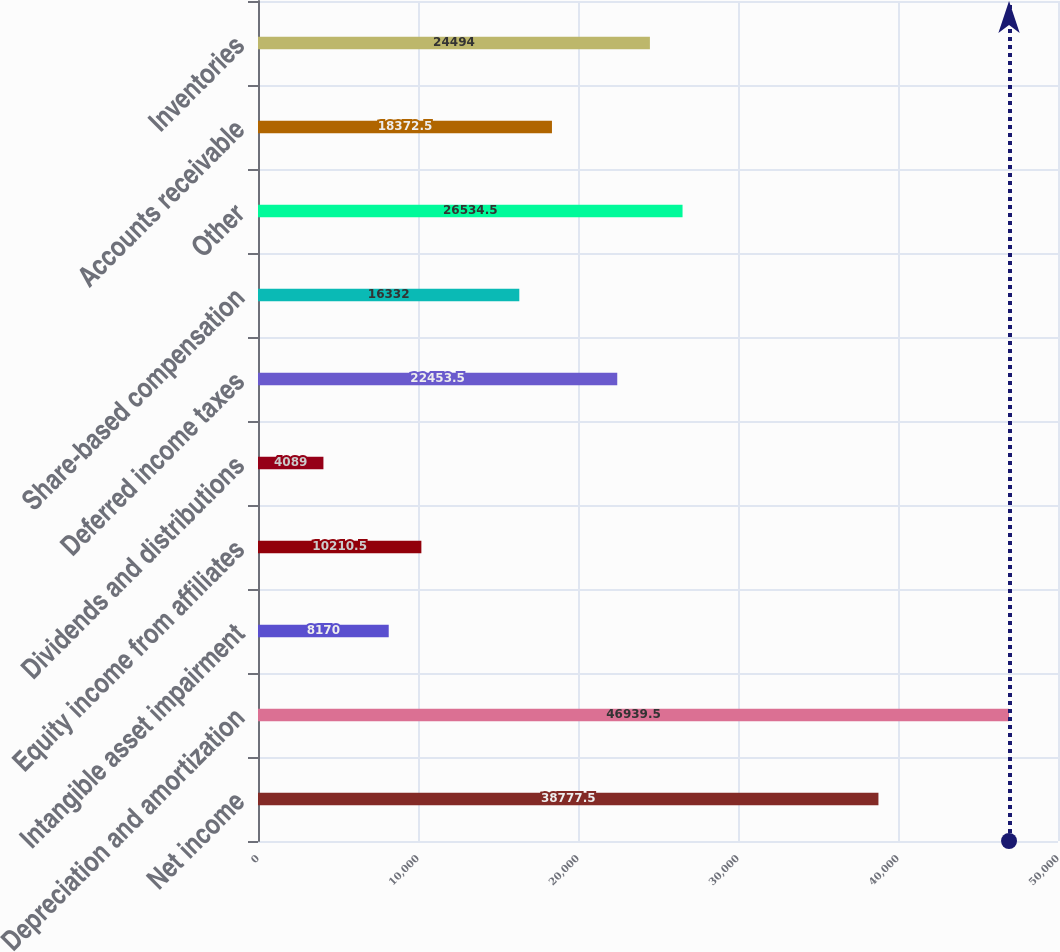Convert chart to OTSL. <chart><loc_0><loc_0><loc_500><loc_500><bar_chart><fcel>Net income<fcel>Depreciation and amortization<fcel>Intangible asset impairment<fcel>Equity income from affiliates<fcel>Dividends and distributions<fcel>Deferred income taxes<fcel>Share-based compensation<fcel>Other<fcel>Accounts receivable<fcel>Inventories<nl><fcel>38777.5<fcel>46939.5<fcel>8170<fcel>10210.5<fcel>4089<fcel>22453.5<fcel>16332<fcel>26534.5<fcel>18372.5<fcel>24494<nl></chart> 